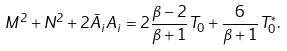<formula> <loc_0><loc_0><loc_500><loc_500>M ^ { 2 } + N ^ { 2 } + 2 \bar { A } _ { i } A _ { i } = 2 \frac { \beta - 2 } { \beta + 1 } T _ { 0 } + \frac { 6 } { \beta + 1 } T _ { 0 } ^ { * } .</formula> 